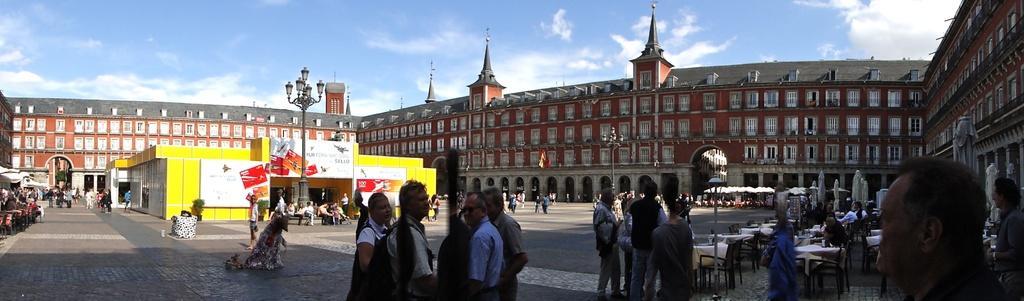How would you summarize this image in a sentence or two? In this picture we can see a group of people standing in the front and discussing something. Behind there is a open restaurant with table and chairs. In the center there is a yellow shop and lamp post. In the background we can see brown building with white windows. On the top there is a sky and clouds. 